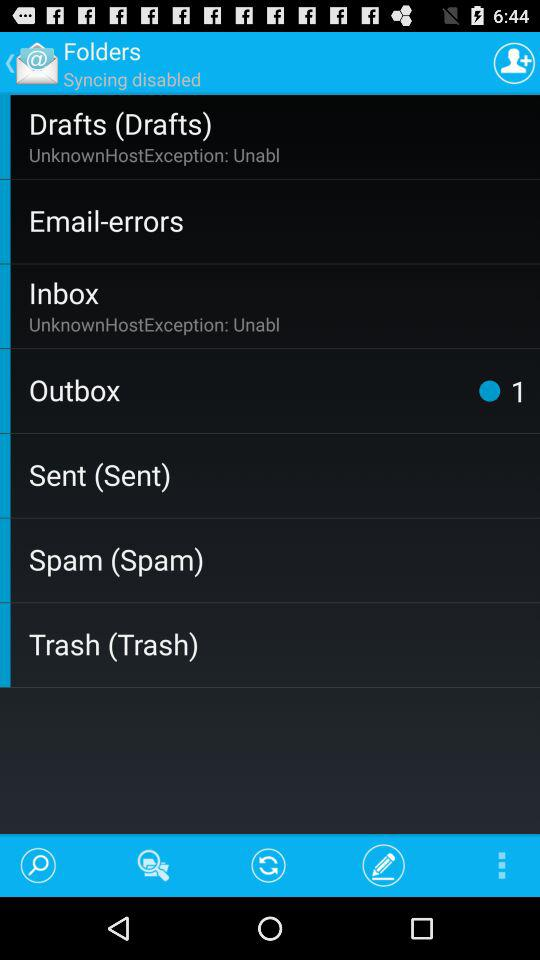How many folders have an error message?
Answer the question using a single word or phrase. 2 